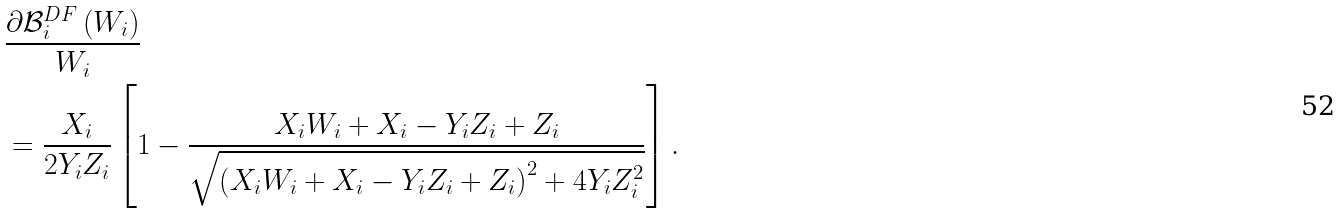<formula> <loc_0><loc_0><loc_500><loc_500>& \frac { { \partial { { \mathcal { B } } _ { i } ^ { D F } } \left ( { W _ { i } } \right ) } } { W _ { i } } \\ & = \frac { X _ { i } } { { 2 { Y _ { i } } { Z _ { i } } } } \left [ { 1 - \frac { { { X _ { i } } { W _ { i } } + { X _ { i } } - { Y _ { i } } { Z _ { i } } + { Z _ { i } } } } { { \sqrt { { { \left ( { { X _ { i } } { W _ { i } } + { X _ { i } } - { Y _ { i } } { Z _ { i } } + { Z _ { i } } } \right ) } ^ { 2 } } + 4 { Y _ { i } } Z _ { i } ^ { 2 } } } } } \right ] .</formula> 